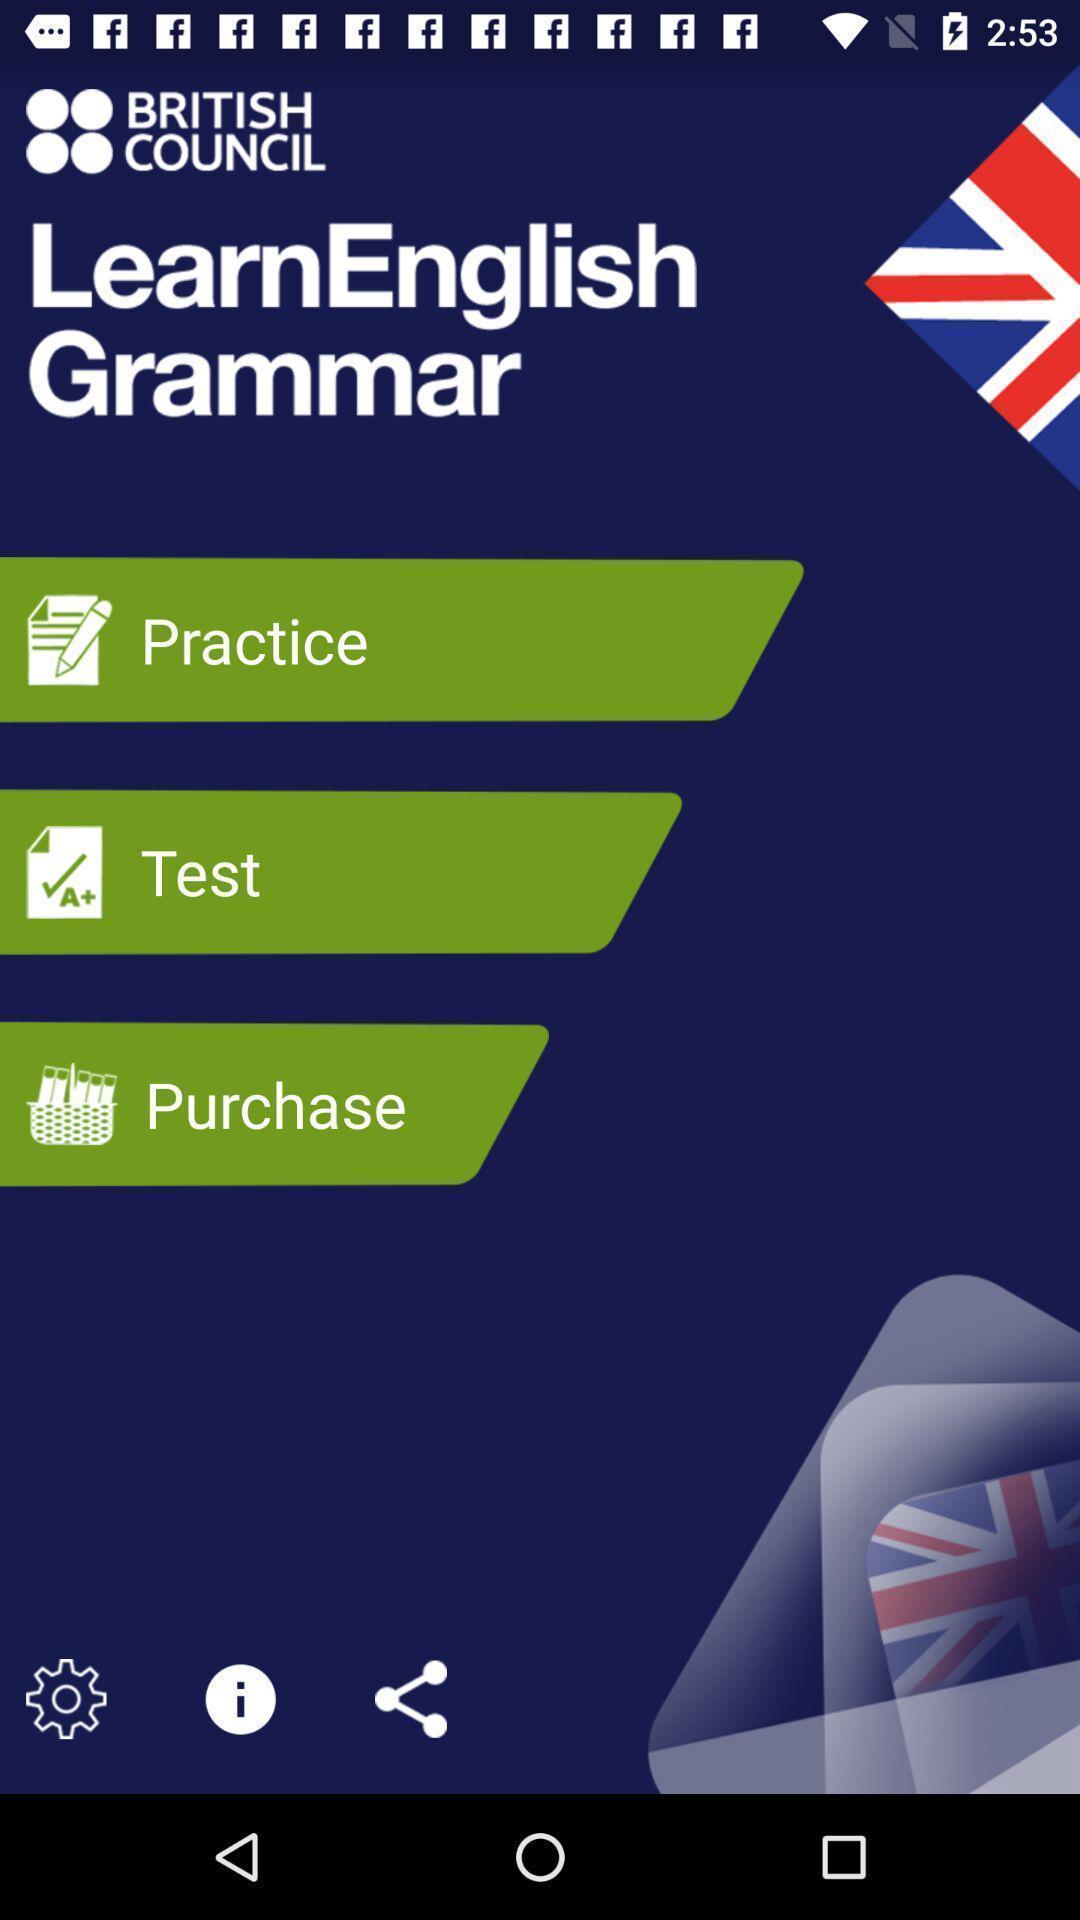Give me a summary of this screen capture. Page showing the options in leaning app. 